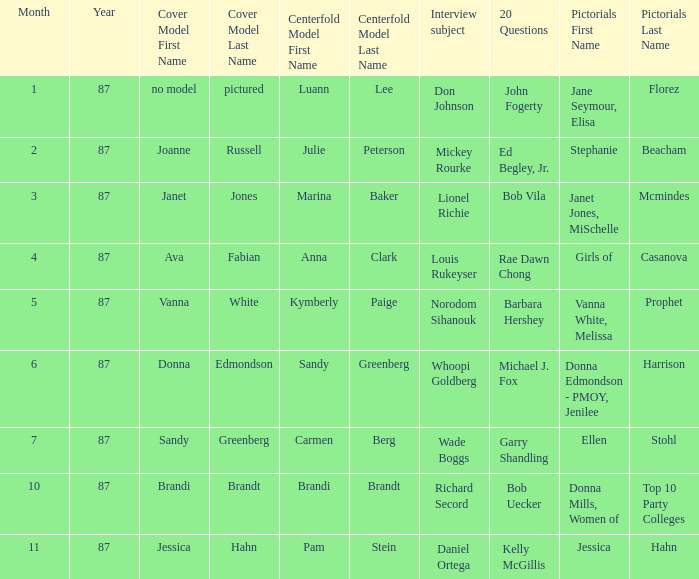Who was on the cover at the time of bob vila's 20 questions involvement? Janet Jones. 